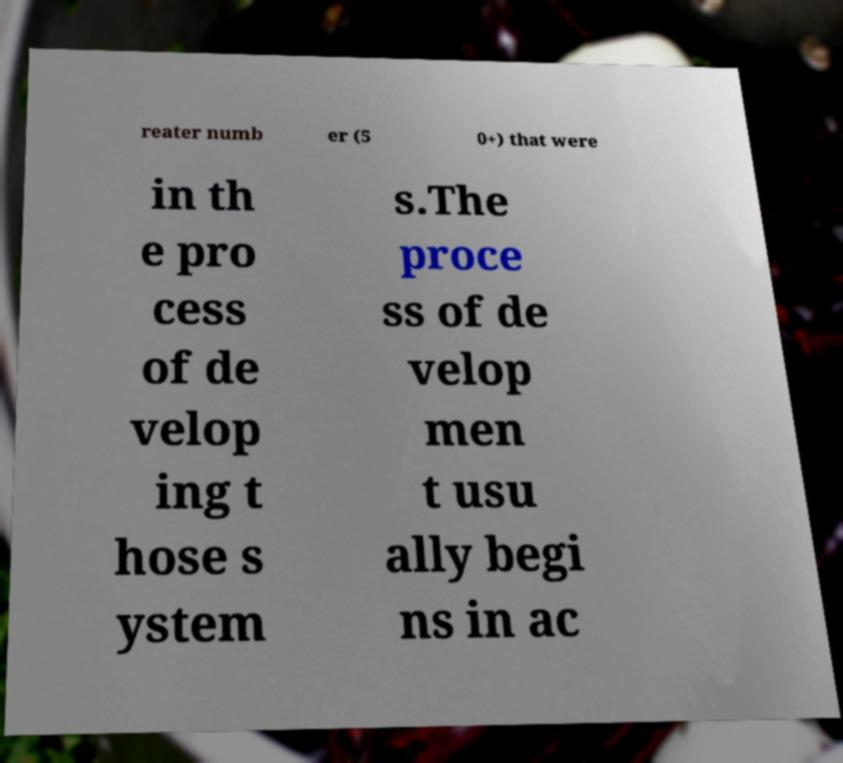For documentation purposes, I need the text within this image transcribed. Could you provide that? reater numb er (5 0+) that were in th e pro cess of de velop ing t hose s ystem s.The proce ss of de velop men t usu ally begi ns in ac 